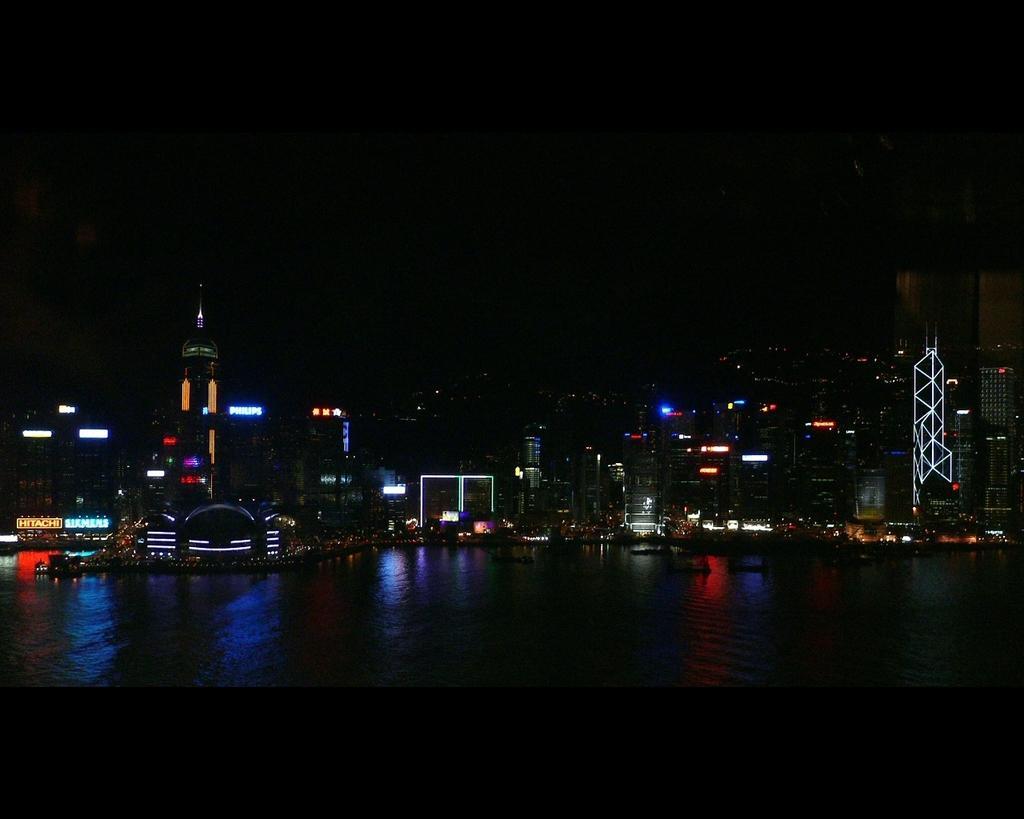Could you give a brief overview of what you see in this image? At the bottom of this image, there is water. In the background, there are buildings which are having lights and the background is dark in color. 